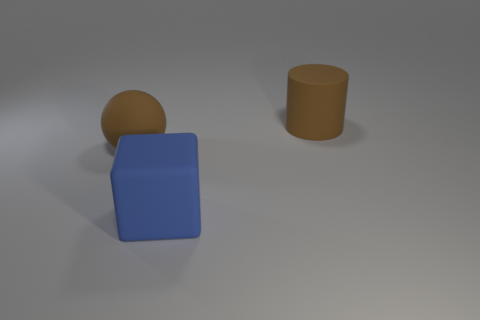How many brown objects are made of the same material as the large cube? Based on the image, there are two brown objects: a sphere and a cylinder. These objects appear to be made of the same matte material as the large blue cube, which suggests that there are indeed two objects that meet the criteria. 